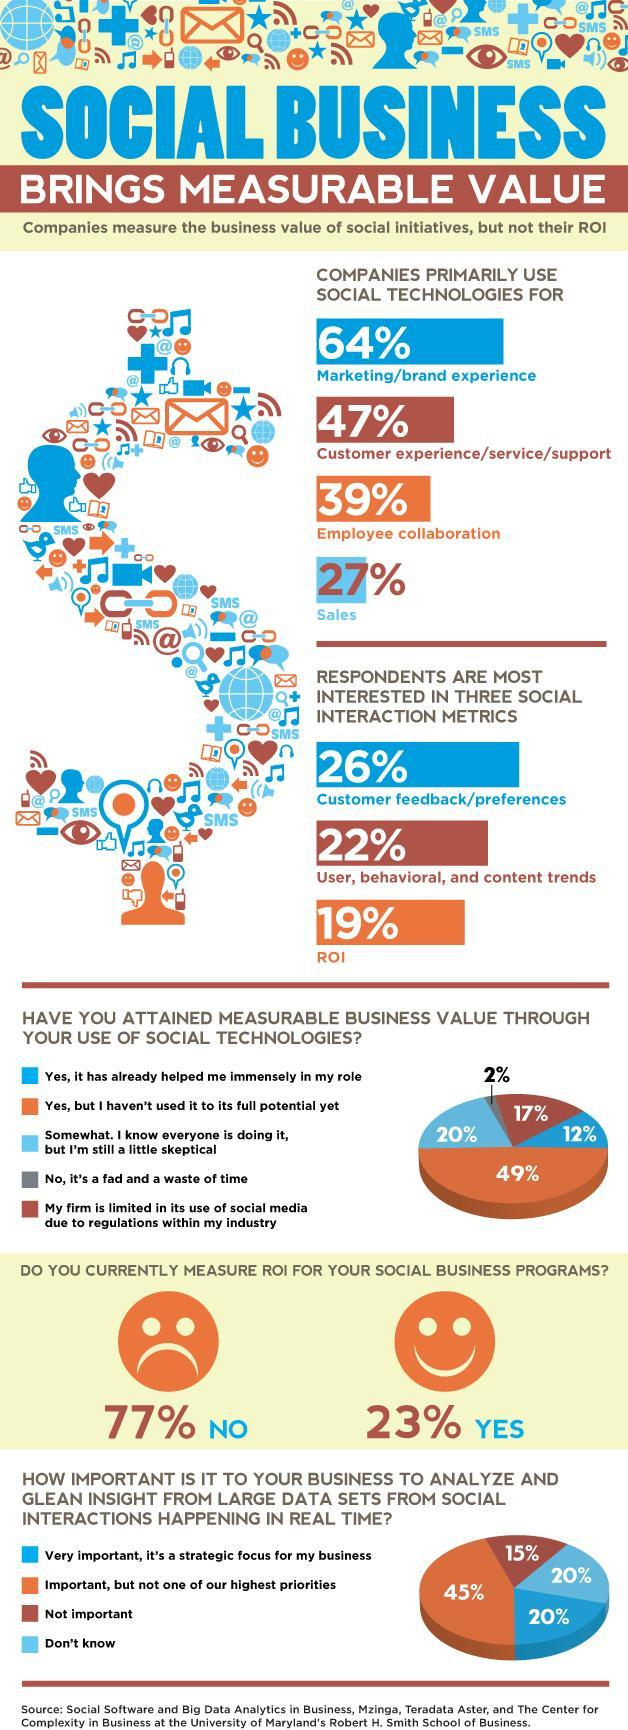Out of the three social interaction metrics, in which one are the respondents least interested in?
Answer the question with a short phrase. ROI What percentage of companies use social technologies for employee collaboration? 39% What percentage of businesses are sceptical about the use of social technologies, even though they know everyone is doing it? 20% What percentage of respondents do not give their highest priority to real-time social interaction analysis? 45% How many social interaction metrics are mentioned? 3 What percentage of respondents feel that social technology is a fad and a waste of time? 2% What percentage of the businesses have limited the use of social media due to the regulations within their industry? 17% What percentage of respondents consider 'analysis of social interactions' to be a strategic focus for the business? 20% What percentage of respondents feel that they have attained a measurable business value through social technologies but haven't used it to its full potential? 49% By what percentage, is the companies using social technologies for customer services higher than those using it for sales? 20% What percentage of companies use social technologies primarily for customer service? 47% What percentage of respondents measure ROI for their business programs? 23% What percentage of businesses do not currently measure ROI for their business programs? 77% What percentage of respondents feel that social technologies have already helped them immensely in their role? 12% What percentage of respondents consider it unimportant to analyse real-time social interactions? 15% How many primary uses of social technologies by companies, are mentioned here? 4 What percentage of respondents consider it very important to analyse real time social interactions? 20% What percentage of companies use social technologies for sales? 27% Out of the three social interaction metrics, in which one are the respondents most interested in? Customer feedback/preferences By what "percent"  is the interest in customer feedback metric higher than the ROI metric? 7 